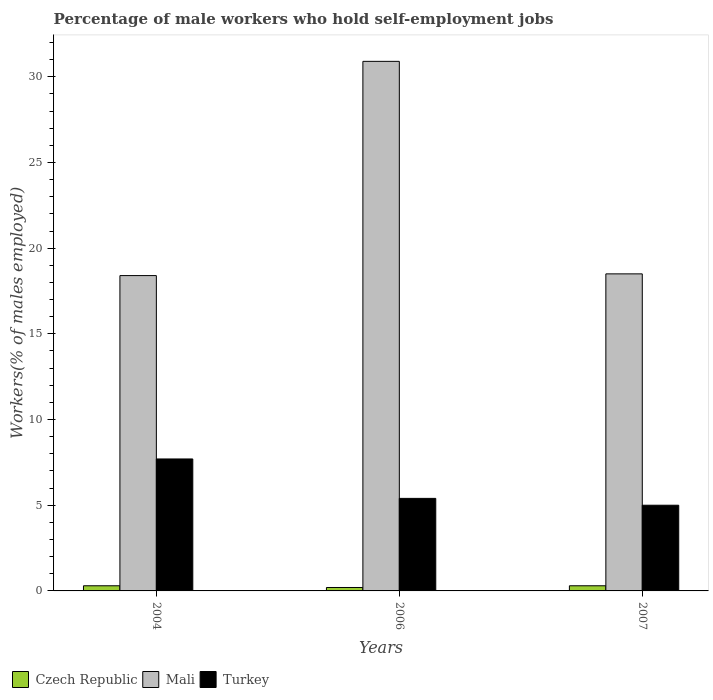How many different coloured bars are there?
Give a very brief answer. 3. Are the number of bars on each tick of the X-axis equal?
Provide a short and direct response. Yes. What is the label of the 3rd group of bars from the left?
Offer a terse response. 2007. In how many cases, is the number of bars for a given year not equal to the number of legend labels?
Ensure brevity in your answer.  0. What is the percentage of self-employed male workers in Mali in 2004?
Your response must be concise. 18.4. Across all years, what is the maximum percentage of self-employed male workers in Turkey?
Your answer should be compact. 7.7. Across all years, what is the minimum percentage of self-employed male workers in Czech Republic?
Offer a terse response. 0.2. In which year was the percentage of self-employed male workers in Mali minimum?
Your response must be concise. 2004. What is the total percentage of self-employed male workers in Mali in the graph?
Provide a succinct answer. 67.8. What is the difference between the percentage of self-employed male workers in Turkey in 2004 and that in 2006?
Provide a succinct answer. 2.3. What is the difference between the percentage of self-employed male workers in Mali in 2007 and the percentage of self-employed male workers in Turkey in 2004?
Make the answer very short. 10.8. What is the average percentage of self-employed male workers in Mali per year?
Make the answer very short. 22.6. In the year 2006, what is the difference between the percentage of self-employed male workers in Turkey and percentage of self-employed male workers in Czech Republic?
Your answer should be very brief. 5.2. In how many years, is the percentage of self-employed male workers in Czech Republic greater than 19 %?
Your answer should be compact. 0. What is the ratio of the percentage of self-employed male workers in Mali in 2004 to that in 2007?
Make the answer very short. 0.99. Is the difference between the percentage of self-employed male workers in Turkey in 2004 and 2006 greater than the difference between the percentage of self-employed male workers in Czech Republic in 2004 and 2006?
Offer a terse response. Yes. What is the difference between the highest and the second highest percentage of self-employed male workers in Turkey?
Ensure brevity in your answer.  2.3. What is the difference between the highest and the lowest percentage of self-employed male workers in Mali?
Offer a very short reply. 12.5. Is the sum of the percentage of self-employed male workers in Czech Republic in 2004 and 2006 greater than the maximum percentage of self-employed male workers in Mali across all years?
Provide a succinct answer. No. What does the 3rd bar from the left in 2004 represents?
Provide a short and direct response. Turkey. What does the 2nd bar from the right in 2004 represents?
Give a very brief answer. Mali. Is it the case that in every year, the sum of the percentage of self-employed male workers in Czech Republic and percentage of self-employed male workers in Mali is greater than the percentage of self-employed male workers in Turkey?
Keep it short and to the point. Yes. How many years are there in the graph?
Provide a succinct answer. 3. Are the values on the major ticks of Y-axis written in scientific E-notation?
Ensure brevity in your answer.  No. Does the graph contain any zero values?
Offer a very short reply. No. Where does the legend appear in the graph?
Provide a short and direct response. Bottom left. What is the title of the graph?
Provide a short and direct response. Percentage of male workers who hold self-employment jobs. Does "St. Martin (French part)" appear as one of the legend labels in the graph?
Keep it short and to the point. No. What is the label or title of the Y-axis?
Your answer should be very brief. Workers(% of males employed). What is the Workers(% of males employed) of Czech Republic in 2004?
Your answer should be very brief. 0.3. What is the Workers(% of males employed) of Mali in 2004?
Give a very brief answer. 18.4. What is the Workers(% of males employed) of Turkey in 2004?
Offer a terse response. 7.7. What is the Workers(% of males employed) in Czech Republic in 2006?
Make the answer very short. 0.2. What is the Workers(% of males employed) in Mali in 2006?
Make the answer very short. 30.9. What is the Workers(% of males employed) of Turkey in 2006?
Your answer should be compact. 5.4. What is the Workers(% of males employed) in Czech Republic in 2007?
Ensure brevity in your answer.  0.3. What is the Workers(% of males employed) of Turkey in 2007?
Your response must be concise. 5. Across all years, what is the maximum Workers(% of males employed) of Czech Republic?
Your answer should be very brief. 0.3. Across all years, what is the maximum Workers(% of males employed) in Mali?
Your answer should be very brief. 30.9. Across all years, what is the maximum Workers(% of males employed) in Turkey?
Ensure brevity in your answer.  7.7. Across all years, what is the minimum Workers(% of males employed) in Czech Republic?
Offer a very short reply. 0.2. Across all years, what is the minimum Workers(% of males employed) in Mali?
Your answer should be very brief. 18.4. Across all years, what is the minimum Workers(% of males employed) of Turkey?
Your response must be concise. 5. What is the total Workers(% of males employed) in Mali in the graph?
Provide a short and direct response. 67.8. What is the total Workers(% of males employed) of Turkey in the graph?
Keep it short and to the point. 18.1. What is the difference between the Workers(% of males employed) of Mali in 2004 and that in 2006?
Ensure brevity in your answer.  -12.5. What is the difference between the Workers(% of males employed) in Turkey in 2004 and that in 2006?
Give a very brief answer. 2.3. What is the difference between the Workers(% of males employed) in Mali in 2004 and that in 2007?
Give a very brief answer. -0.1. What is the difference between the Workers(% of males employed) in Mali in 2006 and that in 2007?
Provide a short and direct response. 12.4. What is the difference between the Workers(% of males employed) of Czech Republic in 2004 and the Workers(% of males employed) of Mali in 2006?
Provide a short and direct response. -30.6. What is the difference between the Workers(% of males employed) in Czech Republic in 2004 and the Workers(% of males employed) in Turkey in 2006?
Keep it short and to the point. -5.1. What is the difference between the Workers(% of males employed) in Czech Republic in 2004 and the Workers(% of males employed) in Mali in 2007?
Your answer should be compact. -18.2. What is the difference between the Workers(% of males employed) of Czech Republic in 2006 and the Workers(% of males employed) of Mali in 2007?
Provide a short and direct response. -18.3. What is the difference between the Workers(% of males employed) of Mali in 2006 and the Workers(% of males employed) of Turkey in 2007?
Make the answer very short. 25.9. What is the average Workers(% of males employed) of Czech Republic per year?
Your response must be concise. 0.27. What is the average Workers(% of males employed) in Mali per year?
Keep it short and to the point. 22.6. What is the average Workers(% of males employed) of Turkey per year?
Ensure brevity in your answer.  6.03. In the year 2004, what is the difference between the Workers(% of males employed) in Czech Republic and Workers(% of males employed) in Mali?
Make the answer very short. -18.1. In the year 2004, what is the difference between the Workers(% of males employed) of Czech Republic and Workers(% of males employed) of Turkey?
Make the answer very short. -7.4. In the year 2004, what is the difference between the Workers(% of males employed) of Mali and Workers(% of males employed) of Turkey?
Provide a short and direct response. 10.7. In the year 2006, what is the difference between the Workers(% of males employed) in Czech Republic and Workers(% of males employed) in Mali?
Ensure brevity in your answer.  -30.7. In the year 2006, what is the difference between the Workers(% of males employed) of Czech Republic and Workers(% of males employed) of Turkey?
Provide a short and direct response. -5.2. In the year 2007, what is the difference between the Workers(% of males employed) of Czech Republic and Workers(% of males employed) of Mali?
Ensure brevity in your answer.  -18.2. In the year 2007, what is the difference between the Workers(% of males employed) of Mali and Workers(% of males employed) of Turkey?
Provide a short and direct response. 13.5. What is the ratio of the Workers(% of males employed) in Mali in 2004 to that in 2006?
Your response must be concise. 0.6. What is the ratio of the Workers(% of males employed) of Turkey in 2004 to that in 2006?
Keep it short and to the point. 1.43. What is the ratio of the Workers(% of males employed) of Czech Republic in 2004 to that in 2007?
Keep it short and to the point. 1. What is the ratio of the Workers(% of males employed) in Turkey in 2004 to that in 2007?
Provide a succinct answer. 1.54. What is the ratio of the Workers(% of males employed) in Czech Republic in 2006 to that in 2007?
Your response must be concise. 0.67. What is the ratio of the Workers(% of males employed) in Mali in 2006 to that in 2007?
Ensure brevity in your answer.  1.67. What is the difference between the highest and the second highest Workers(% of males employed) of Mali?
Your answer should be very brief. 12.4. What is the difference between the highest and the lowest Workers(% of males employed) of Czech Republic?
Ensure brevity in your answer.  0.1. What is the difference between the highest and the lowest Workers(% of males employed) in Turkey?
Provide a succinct answer. 2.7. 